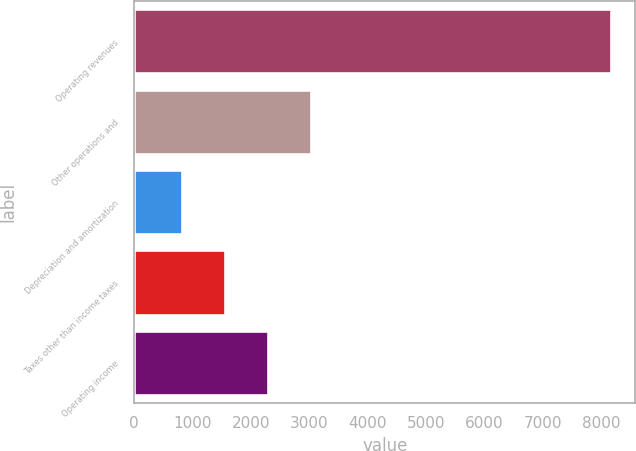Convert chart to OTSL. <chart><loc_0><loc_0><loc_500><loc_500><bar_chart><fcel>Operating revenues<fcel>Other operations and<fcel>Depreciation and amortization<fcel>Taxes other than income taxes<fcel>Operating income<nl><fcel>8172<fcel>3025.6<fcel>820<fcel>1555.2<fcel>2290.4<nl></chart> 